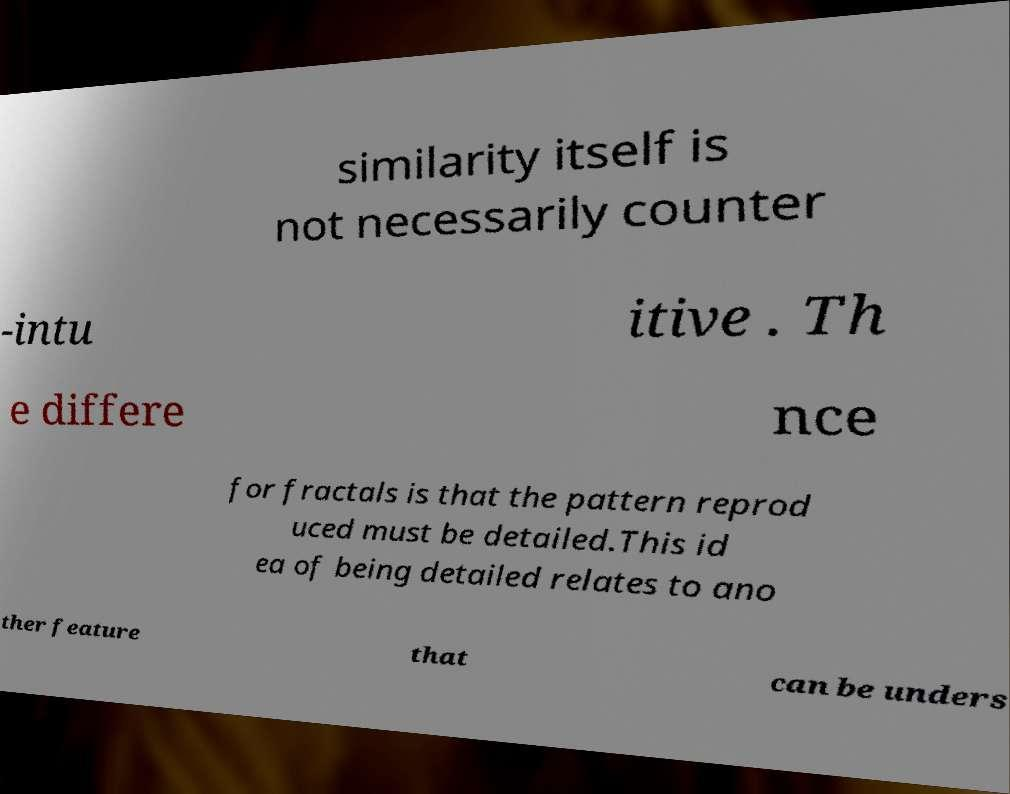Please identify and transcribe the text found in this image. similarity itself is not necessarily counter -intu itive . Th e differe nce for fractals is that the pattern reprod uced must be detailed.This id ea of being detailed relates to ano ther feature that can be unders 